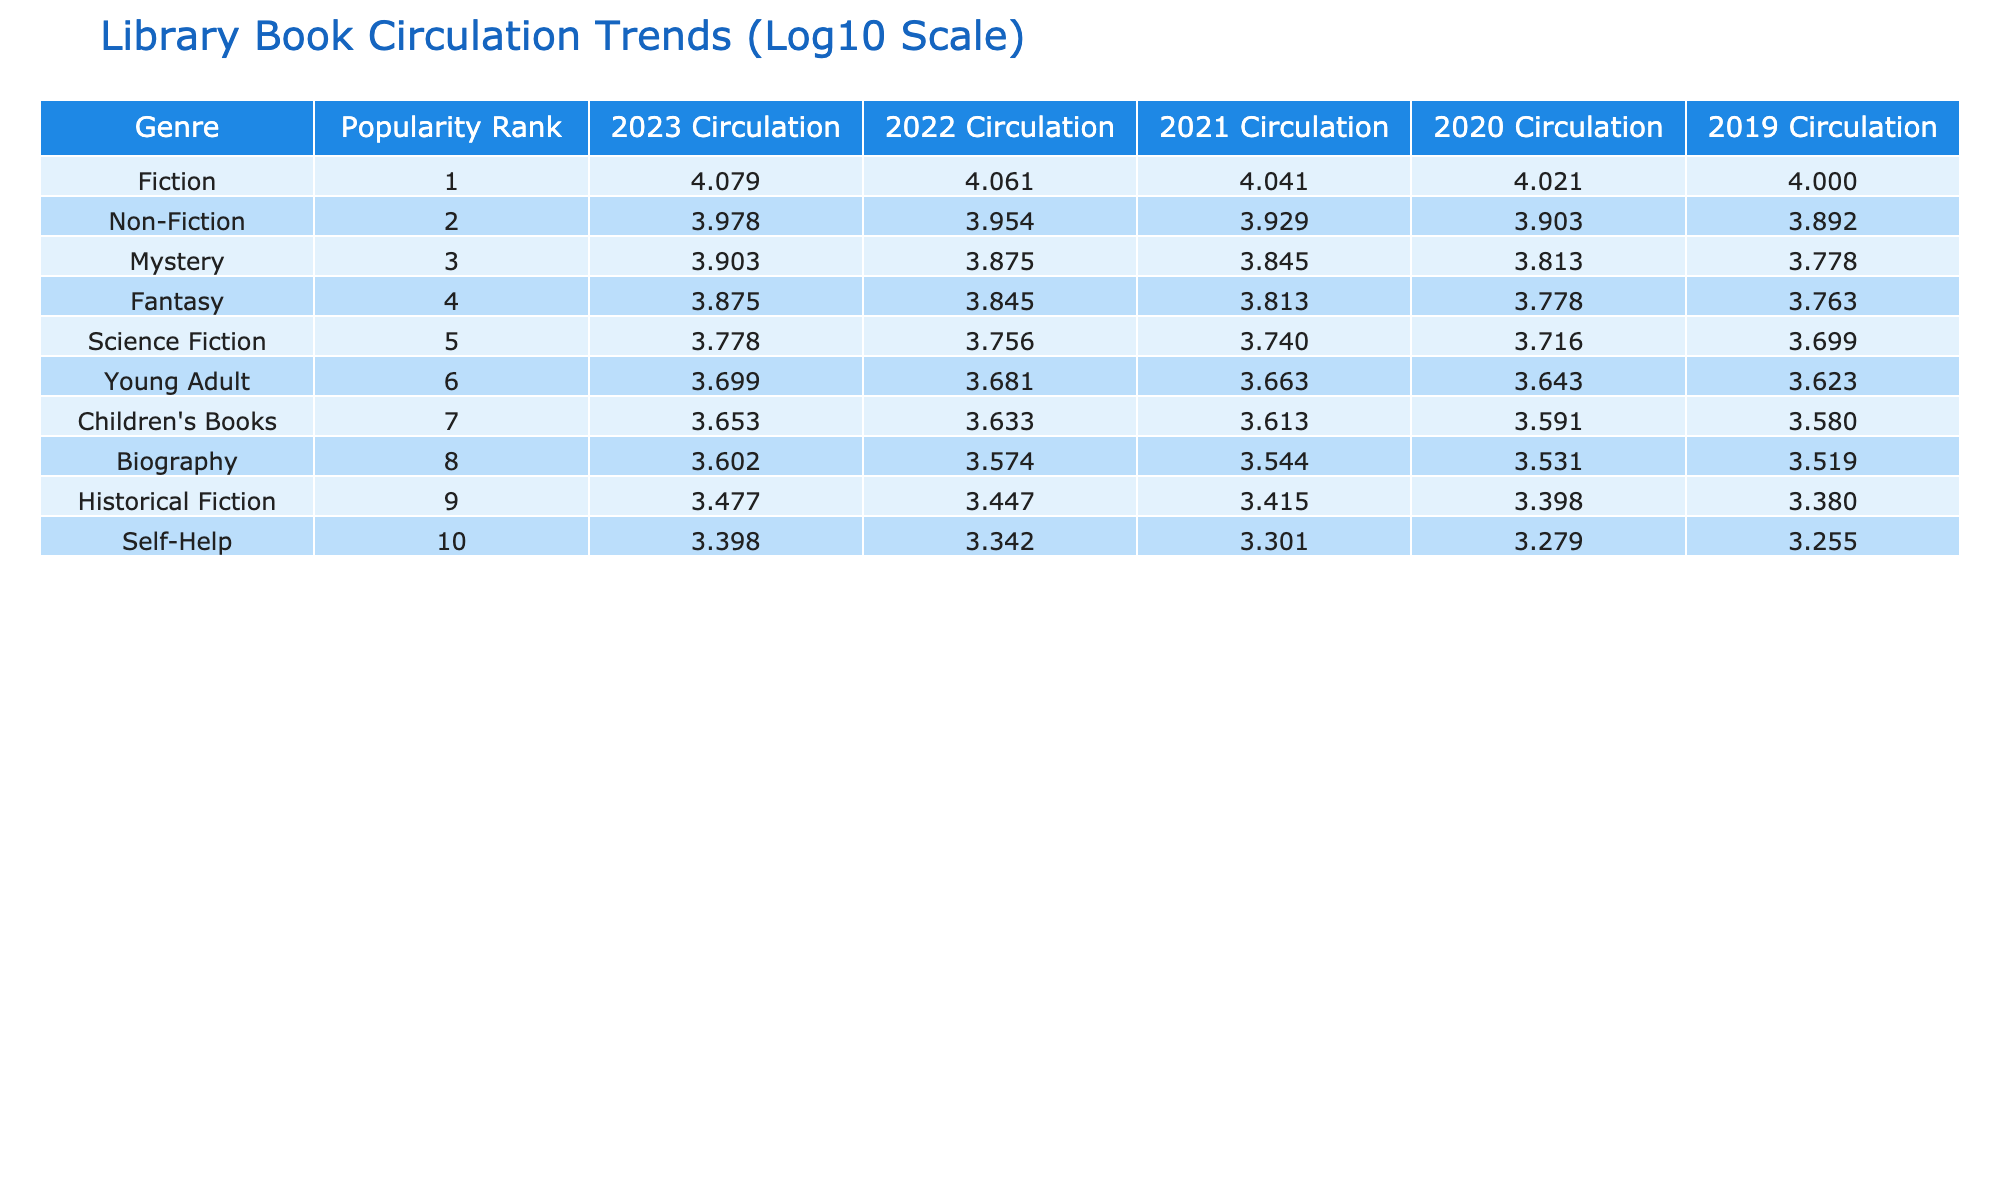What was the circulation of Fiction books in 2023? According to the table, the circulation of Fiction books in 2023 is listed as 12000.
Answer: 12000 Which genre had the lowest circulation in 2022? The table shows that Children's Books had the lowest circulation in 2022 with a value of 4300.
Answer: Children's Books What is the total circulation for Non-Fiction books over the years 2019 to 2023? We add the circulation values for Non-Fiction from 2019 to 2023: 7800 + 8000 + 8500 + 9000 + 9500 = 41800.
Answer: 41800 Did the circulation of Science Fiction books increase every year from 2019 to 2023? The values for Science Fiction from 2019 (5000) to 2023 (6000) show consistent yearly increases: 5200, 5500, 5700, and 6000. Hence, the answer is yes.
Answer: Yes What is the percentage increase in circulation for Young Adult books from 2022 to 2023? The circulation for Young Adult books was 4800 in 2022 and 5000 in 2023. The increase is calculated as (5000 - 4800) / 4800 * 100 = 4.17%.
Answer: 4.17% Which genre had a higher circulation in 2021, Fantasy or Mystery? The table shows that Fantasy had a circulation of 6500 in 2021, whereas Mystery had 7000. Since 7000 is greater than 6500, Mystery had a higher circulation.
Answer: Mystery What was the average circulation of Biography books between 2019 and 2023? We calculate the average of the circulation values for Biography from 2019 to 2023: (3300 + 3400 + 3500 + 3750 + 4000) / 5 = 3570.
Answer: 3570 Was the increase in circulation for Children's Books greater than 1000 from 2019 to 2023? The circulation for Children's Books increased from 3800 in 2019 to 4500 in 2023, which is an increase of 700. Since 700 is less than 1000, the answer is no.
Answer: No Which genres had a circulation of over 9000 in 2023? The table indicates that Fiction (12000) and Non-Fiction (9500) both had circulation numbers over 9000 in 2023. The answer includes both these genres.
Answer: Fiction and Non-Fiction 